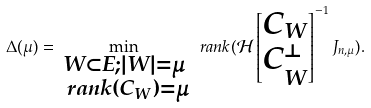Convert formula to latex. <formula><loc_0><loc_0><loc_500><loc_500>\Delta ( \mu ) = \min _ { \substack { W \subset E ; | W | = \mu \\ \ r a n k ( C _ { W } ) = \mu } } \ r a n k ( \mathcal { H } \begin{bmatrix} C _ { W } \\ C _ { W } ^ { \perp } \\ \end{bmatrix} ^ { - 1 } J _ { n , \mu } ) .</formula> 